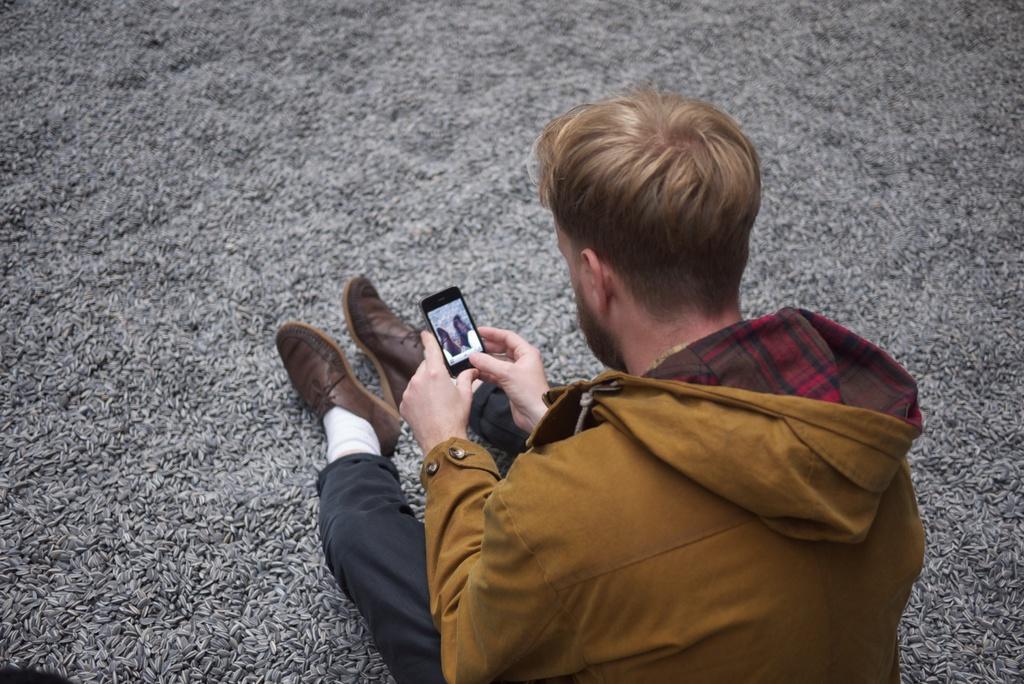How would you summarize this image in a sentence or two? In this picture there is a man sitting on the floor and he is capturing the image 